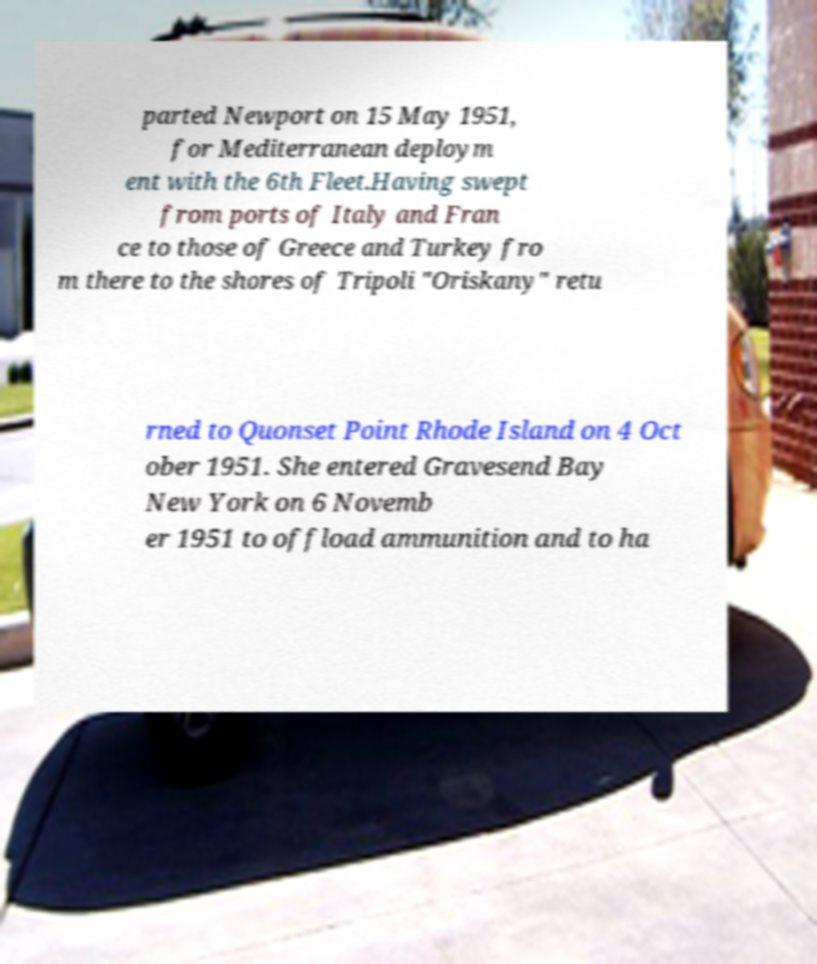Can you accurately transcribe the text from the provided image for me? parted Newport on 15 May 1951, for Mediterranean deploym ent with the 6th Fleet.Having swept from ports of Italy and Fran ce to those of Greece and Turkey fro m there to the shores of Tripoli "Oriskany" retu rned to Quonset Point Rhode Island on 4 Oct ober 1951. She entered Gravesend Bay New York on 6 Novemb er 1951 to offload ammunition and to ha 